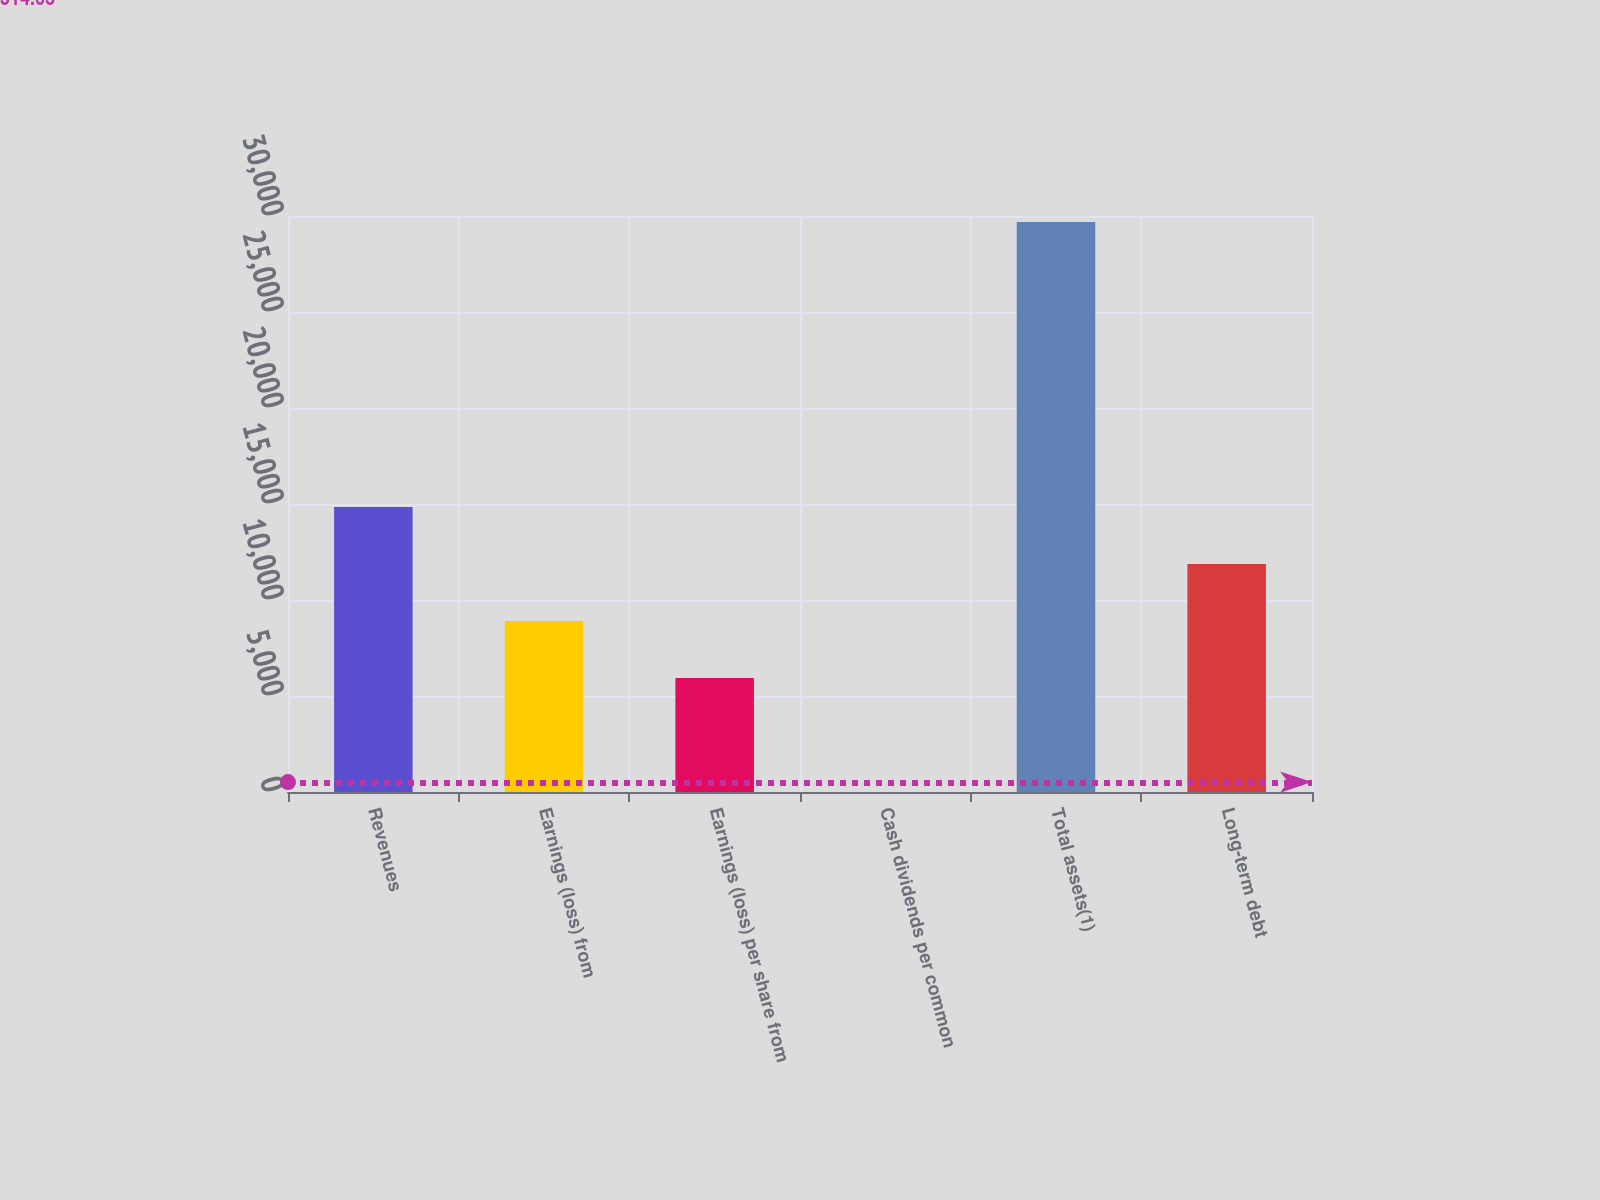<chart> <loc_0><loc_0><loc_500><loc_500><bar_chart><fcel>Revenues<fcel>Earnings (loss) from<fcel>Earnings (loss) per share from<fcel>Cash dividends per common<fcel>Total assets(1)<fcel>Long-term debt<nl><fcel>14843.3<fcel>8906.26<fcel>5937.72<fcel>0.64<fcel>29686<fcel>11874.8<nl></chart> 